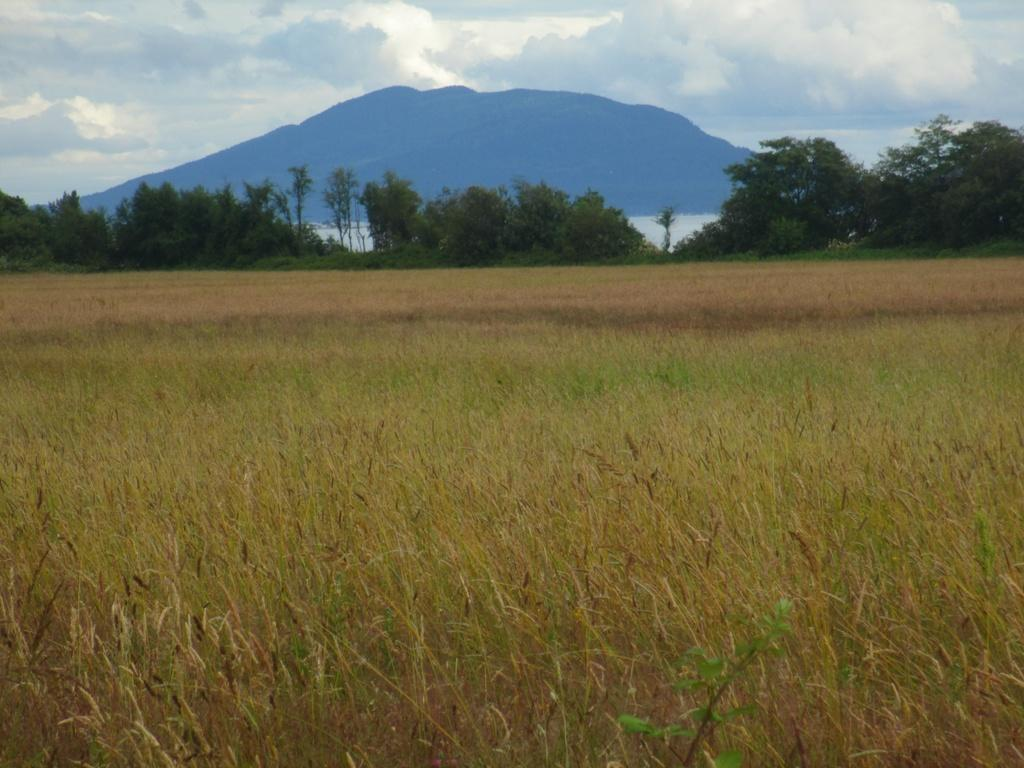What type of vegetation can be seen in the image? There are trees and plants in the image. What type of ground cover is visible in the image? There is grass in the image. What natural feature can be seen in the image? There are mountains in the image. What is the primary source of water in the image? There is water in the image. What can be seen in the background of the image? The sky is visible in the background of the image. What atmospheric conditions are present in the sky? Clouds are present in the sky. How many cars are parked near the trees in the image? There are no cars present in the image; it features trees, plants, grass, water, mountains, and a sky with clouds. 